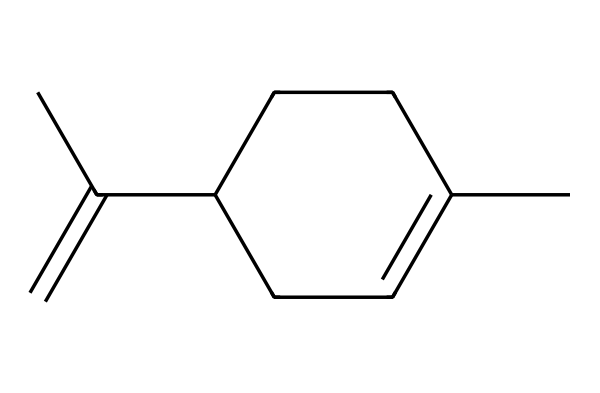What is the molecular formula of limonene? To derive the molecular formula from the SMILES representation, count the carbon (C) and hydrogen (H) atoms present in the chain and branches. The structure indicates 10 carbons and 16 hydrogens. Hence, the molecular formula is C10H16.
Answer: C10H16 How many rings are present in limonene? Upon examining the structure given by the SMILES notation, there is no closed-loop structure represented. Limonene has an open-chain structure and is thus acyclic with no rings.
Answer: 0 What type of compound is limonene? Limonene is classified as a terpene, specifically a monoterpene due to its structure containing 10 carbon atoms derived from two isoprene units.
Answer: terpene What is the presence of double bonds in limonene? In the SMILES representation, the "C(=C)" notation indicates a carbon-carbon double bond. There is one double bond present in the structure of limonene.
Answer: 1 Is limonene polar or non-polar? Limonene consists mainly of hydrocarbons with a hydrophobic structure, making it predominantly non-polar as it lacks significant electronegative atoms or functional groups.
Answer: non-polar What role does limonene play in air fresheners? Limonene serves as a fragrance component due to its pleasant citrus scent and is commonly included in air fresheners to impart a fresh aroma.
Answer: fragrance 